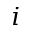Convert formula to latex. <formula><loc_0><loc_0><loc_500><loc_500>i</formula> 